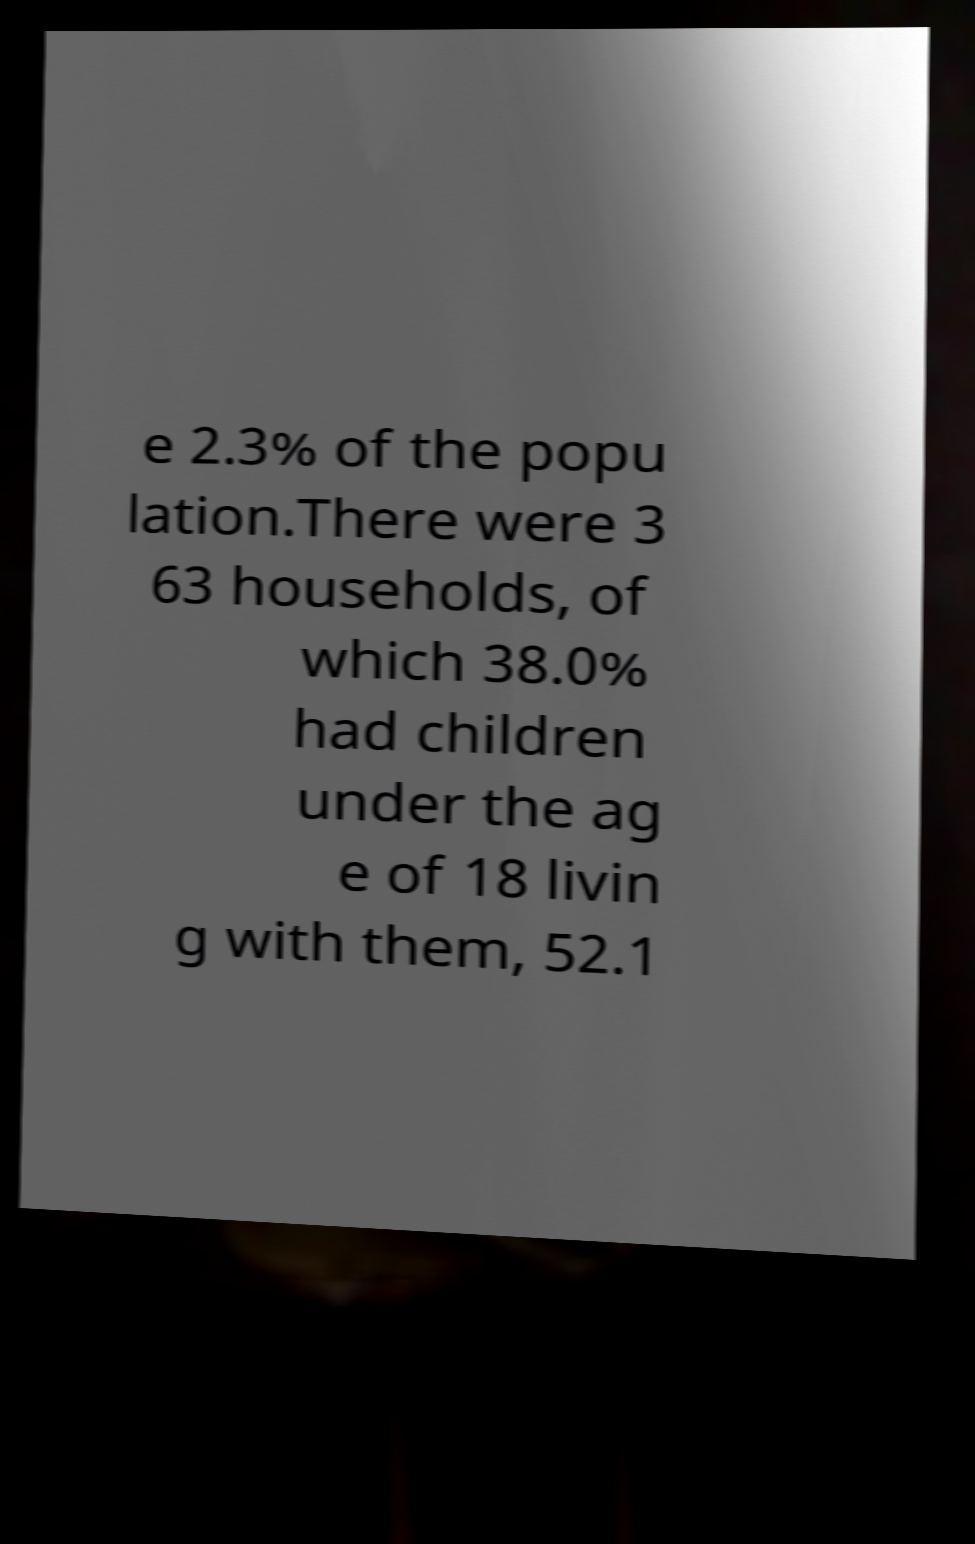Can you accurately transcribe the text from the provided image for me? e 2.3% of the popu lation.There were 3 63 households, of which 38.0% had children under the ag e of 18 livin g with them, 52.1 